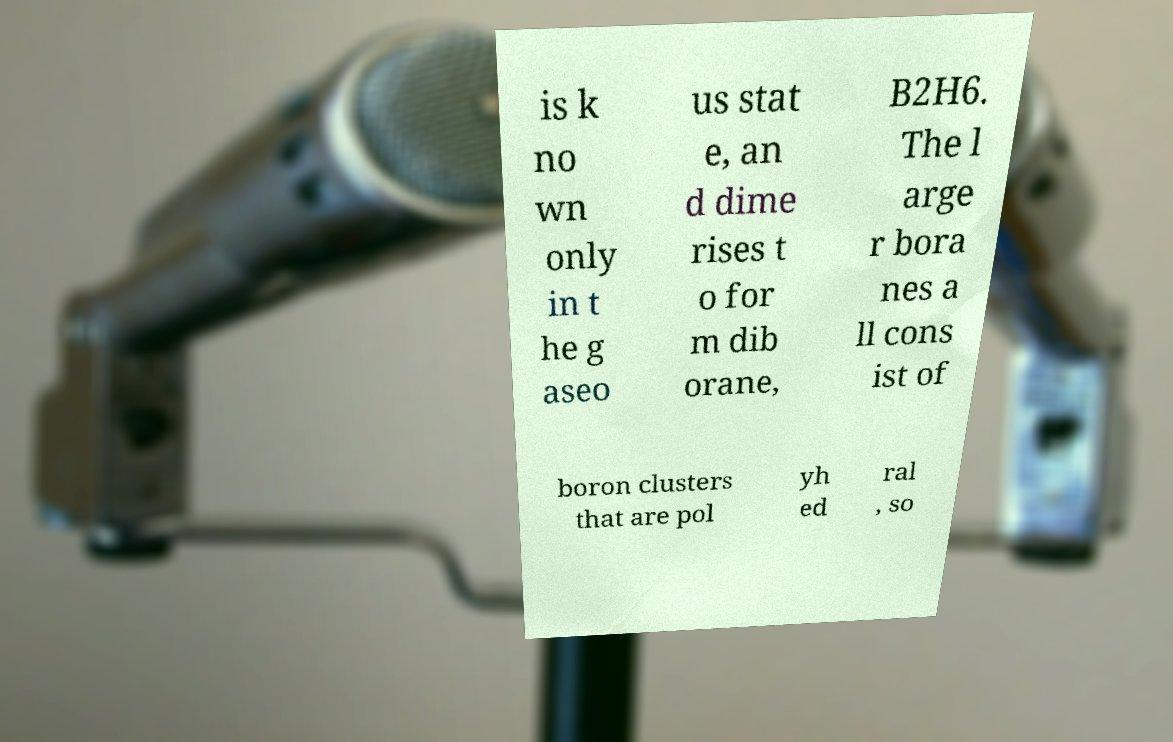There's text embedded in this image that I need extracted. Can you transcribe it verbatim? is k no wn only in t he g aseo us stat e, an d dime rises t o for m dib orane, B2H6. The l arge r bora nes a ll cons ist of boron clusters that are pol yh ed ral , so 